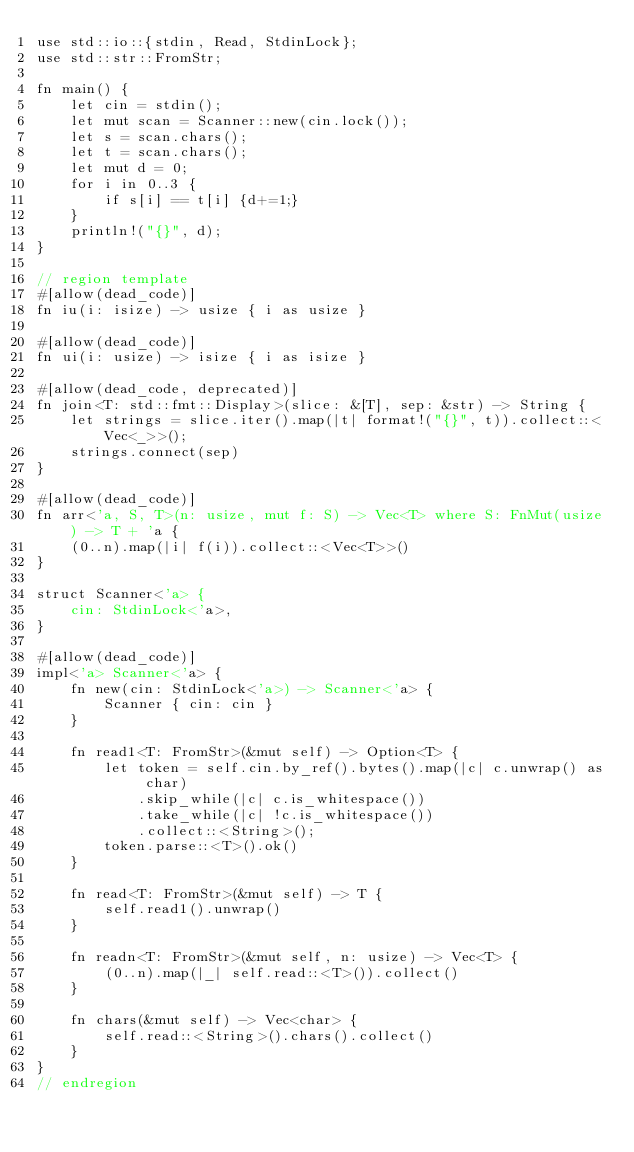<code> <loc_0><loc_0><loc_500><loc_500><_Rust_>use std::io::{stdin, Read, StdinLock};
use std::str::FromStr;

fn main() {
    let cin = stdin();
    let mut scan = Scanner::new(cin.lock());
    let s = scan.chars();
    let t = scan.chars();
    let mut d = 0;
    for i in 0..3 {
        if s[i] == t[i] {d+=1;}
    }
    println!("{}", d);
}

// region template
#[allow(dead_code)]
fn iu(i: isize) -> usize { i as usize }

#[allow(dead_code)]
fn ui(i: usize) -> isize { i as isize }

#[allow(dead_code, deprecated)]
fn join<T: std::fmt::Display>(slice: &[T], sep: &str) -> String {
    let strings = slice.iter().map(|t| format!("{}", t)).collect::<Vec<_>>();
    strings.connect(sep)
}

#[allow(dead_code)]
fn arr<'a, S, T>(n: usize, mut f: S) -> Vec<T> where S: FnMut(usize) -> T + 'a {
    (0..n).map(|i| f(i)).collect::<Vec<T>>()
}

struct Scanner<'a> {
    cin: StdinLock<'a>,
}

#[allow(dead_code)]
impl<'a> Scanner<'a> {
    fn new(cin: StdinLock<'a>) -> Scanner<'a> {
        Scanner { cin: cin }
    }

    fn read1<T: FromStr>(&mut self) -> Option<T> {
        let token = self.cin.by_ref().bytes().map(|c| c.unwrap() as char)
            .skip_while(|c| c.is_whitespace())
            .take_while(|c| !c.is_whitespace())
            .collect::<String>();
        token.parse::<T>().ok()
    }

    fn read<T: FromStr>(&mut self) -> T {
        self.read1().unwrap()
    }

    fn readn<T: FromStr>(&mut self, n: usize) -> Vec<T> {
        (0..n).map(|_| self.read::<T>()).collect()
    }

    fn chars(&mut self) -> Vec<char> {
        self.read::<String>().chars().collect()
    }
}
// endregion</code> 